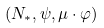Convert formula to latex. <formula><loc_0><loc_0><loc_500><loc_500>( N _ { \ast } , \psi , \mu \cdot \varphi )</formula> 